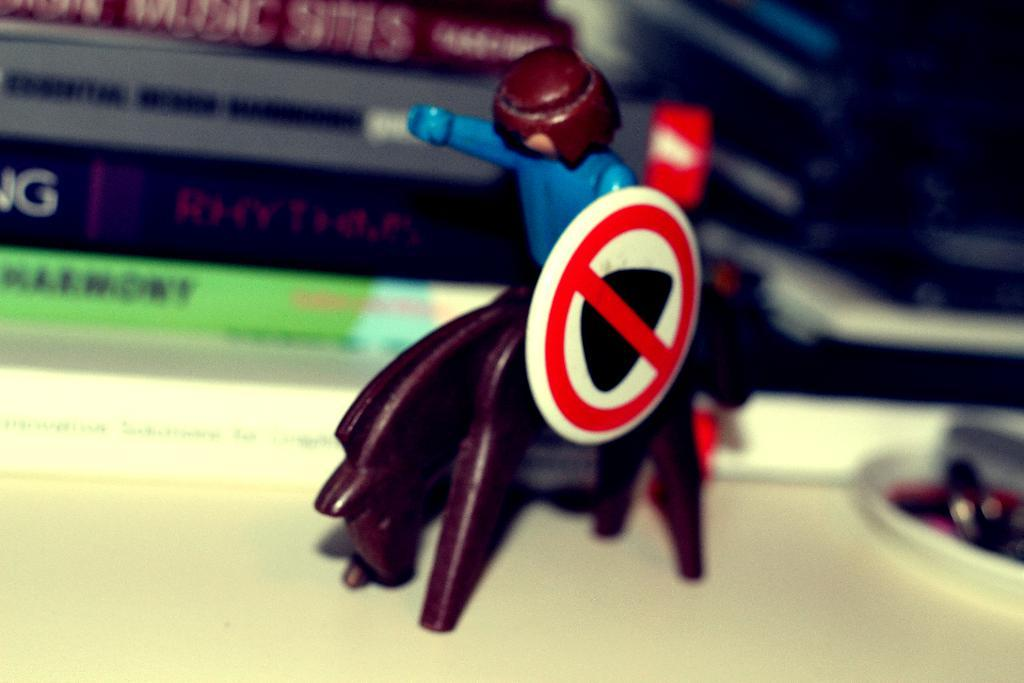What is the main subject of the image? There is a miniature toy in the image. Where is the toy located? The toy is on top of a table. What else can be seen in the image? There are books placed behind the toy. What type of glove is being used to hold the miniature toy in the image? There is no glove present in the image, and the toy is not being held by anything. 